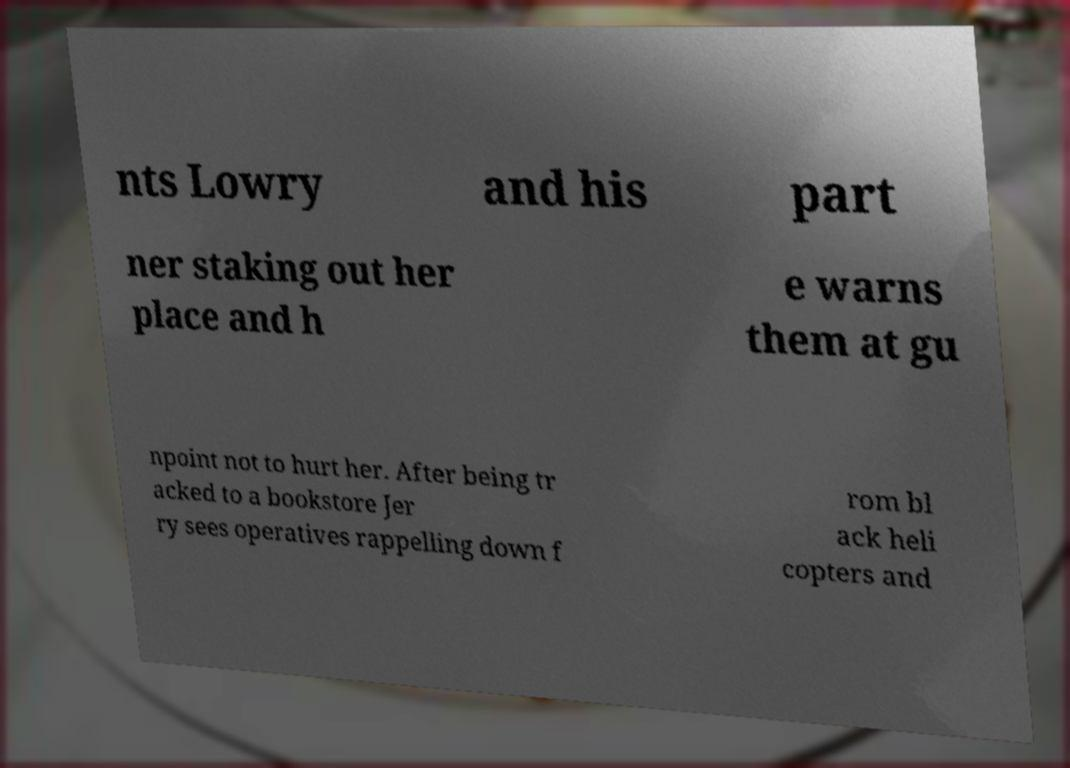Can you accurately transcribe the text from the provided image for me? nts Lowry and his part ner staking out her place and h e warns them at gu npoint not to hurt her. After being tr acked to a bookstore Jer ry sees operatives rappelling down f rom bl ack heli copters and 